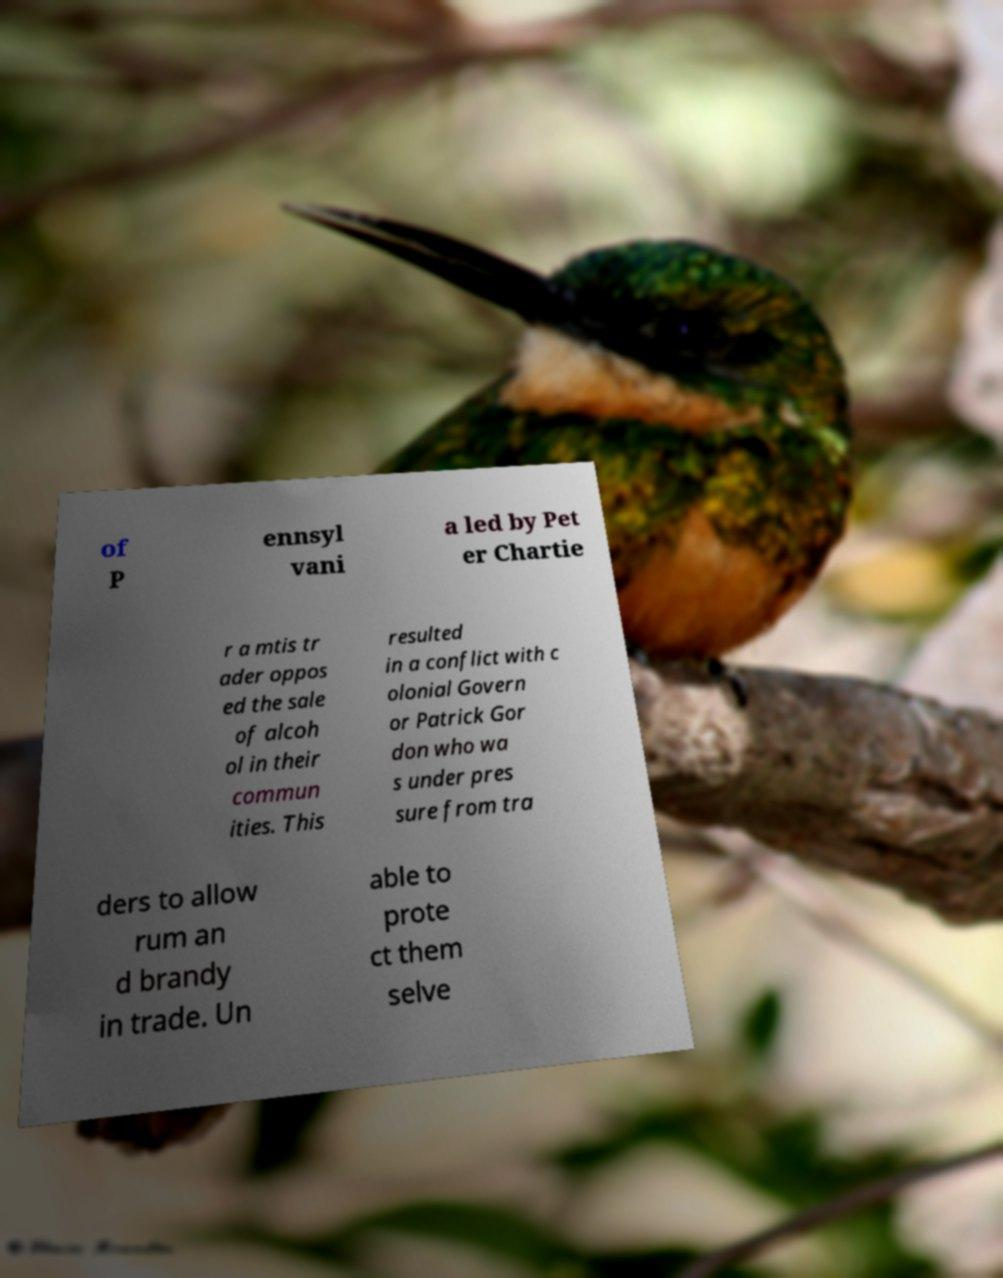There's text embedded in this image that I need extracted. Can you transcribe it verbatim? of P ennsyl vani a led by Pet er Chartie r a mtis tr ader oppos ed the sale of alcoh ol in their commun ities. This resulted in a conflict with c olonial Govern or Patrick Gor don who wa s under pres sure from tra ders to allow rum an d brandy in trade. Un able to prote ct them selve 